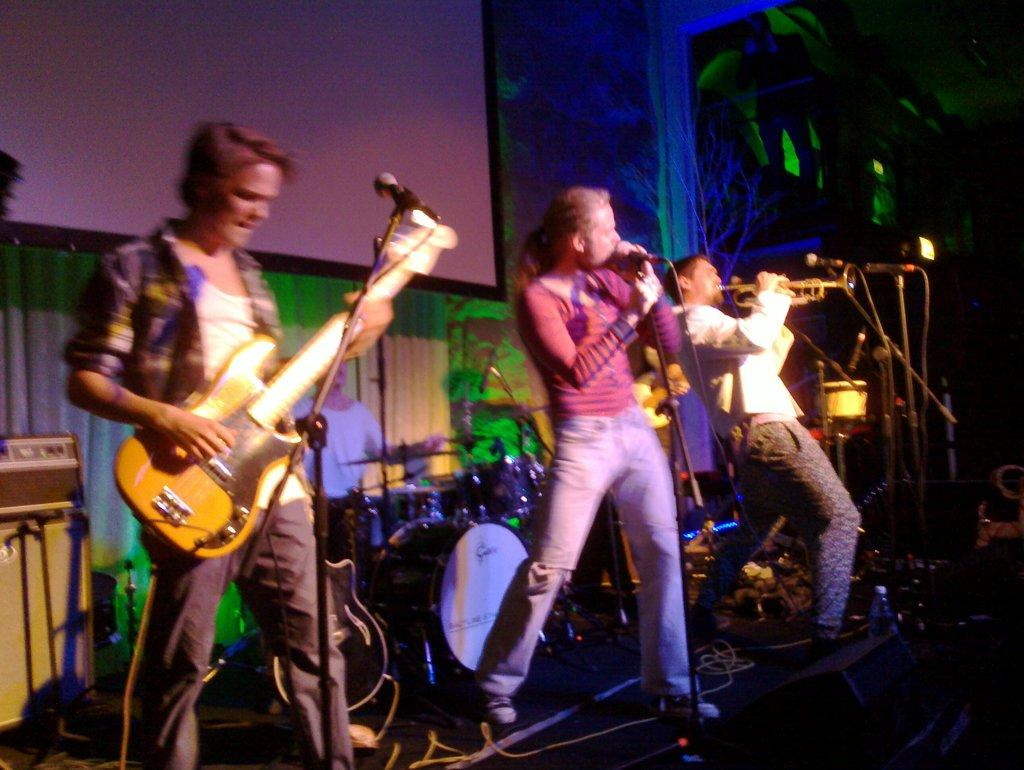What are the people on the stage doing? The people on the stage are performing by playing musical instruments. Is there anyone else on the stage besides the musicians? Yes, there is a person singing on a microphone. What can be seen in the background behind the performers? There is a screen and a banner in the background. Can you see any dinosaurs on the stage during the performance? No, there are no dinosaurs present in the image. Are there any tomatoes being used as part of the performance? No, there are no tomatoes visible in the image. 